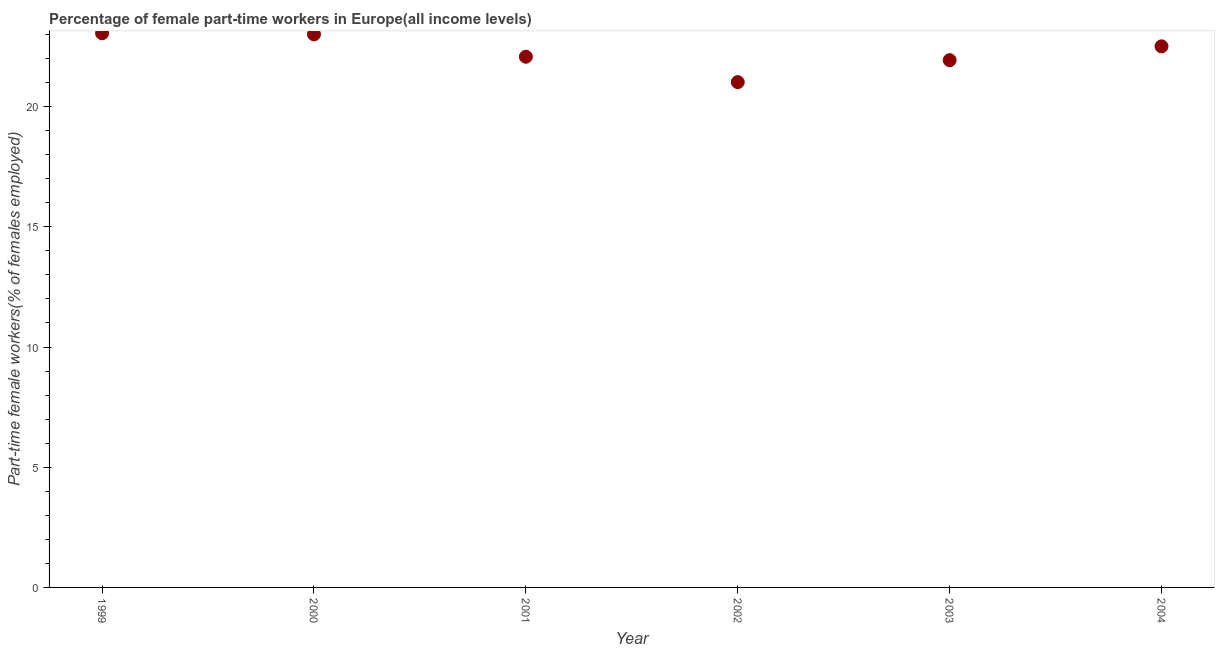What is the percentage of part-time female workers in 1999?
Provide a short and direct response. 23.05. Across all years, what is the maximum percentage of part-time female workers?
Your answer should be compact. 23.05. Across all years, what is the minimum percentage of part-time female workers?
Provide a short and direct response. 21.02. In which year was the percentage of part-time female workers maximum?
Your response must be concise. 1999. In which year was the percentage of part-time female workers minimum?
Keep it short and to the point. 2002. What is the sum of the percentage of part-time female workers?
Provide a short and direct response. 133.58. What is the difference between the percentage of part-time female workers in 1999 and 2001?
Keep it short and to the point. 0.98. What is the average percentage of part-time female workers per year?
Your answer should be compact. 22.26. What is the median percentage of part-time female workers?
Make the answer very short. 22.29. Do a majority of the years between 2003 and 2002 (inclusive) have percentage of part-time female workers greater than 22 %?
Ensure brevity in your answer.  No. What is the ratio of the percentage of part-time female workers in 1999 to that in 2004?
Your answer should be very brief. 1.02. Is the percentage of part-time female workers in 2001 less than that in 2003?
Your answer should be very brief. No. Is the difference between the percentage of part-time female workers in 2002 and 2003 greater than the difference between any two years?
Give a very brief answer. No. What is the difference between the highest and the second highest percentage of part-time female workers?
Offer a terse response. 0.04. What is the difference between the highest and the lowest percentage of part-time female workers?
Your response must be concise. 2.03. Does the graph contain any zero values?
Your answer should be compact. No. Does the graph contain grids?
Offer a very short reply. No. What is the title of the graph?
Your answer should be compact. Percentage of female part-time workers in Europe(all income levels). What is the label or title of the X-axis?
Give a very brief answer. Year. What is the label or title of the Y-axis?
Make the answer very short. Part-time female workers(% of females employed). What is the Part-time female workers(% of females employed) in 1999?
Make the answer very short. 23.05. What is the Part-time female workers(% of females employed) in 2000?
Ensure brevity in your answer.  23. What is the Part-time female workers(% of females employed) in 2001?
Your response must be concise. 22.07. What is the Part-time female workers(% of females employed) in 2002?
Your answer should be very brief. 21.02. What is the Part-time female workers(% of females employed) in 2003?
Make the answer very short. 21.93. What is the Part-time female workers(% of females employed) in 2004?
Ensure brevity in your answer.  22.51. What is the difference between the Part-time female workers(% of females employed) in 1999 and 2000?
Provide a succinct answer. 0.04. What is the difference between the Part-time female workers(% of females employed) in 1999 and 2001?
Your answer should be compact. 0.98. What is the difference between the Part-time female workers(% of females employed) in 1999 and 2002?
Keep it short and to the point. 2.03. What is the difference between the Part-time female workers(% of females employed) in 1999 and 2003?
Your answer should be very brief. 1.12. What is the difference between the Part-time female workers(% of females employed) in 1999 and 2004?
Keep it short and to the point. 0.54. What is the difference between the Part-time female workers(% of females employed) in 2000 and 2001?
Provide a short and direct response. 0.93. What is the difference between the Part-time female workers(% of females employed) in 2000 and 2002?
Keep it short and to the point. 1.99. What is the difference between the Part-time female workers(% of females employed) in 2000 and 2003?
Offer a very short reply. 1.07. What is the difference between the Part-time female workers(% of females employed) in 2000 and 2004?
Keep it short and to the point. 0.5. What is the difference between the Part-time female workers(% of females employed) in 2001 and 2002?
Provide a succinct answer. 1.06. What is the difference between the Part-time female workers(% of females employed) in 2001 and 2003?
Your answer should be compact. 0.14. What is the difference between the Part-time female workers(% of females employed) in 2001 and 2004?
Your answer should be very brief. -0.43. What is the difference between the Part-time female workers(% of females employed) in 2002 and 2003?
Offer a terse response. -0.91. What is the difference between the Part-time female workers(% of females employed) in 2002 and 2004?
Provide a succinct answer. -1.49. What is the difference between the Part-time female workers(% of females employed) in 2003 and 2004?
Provide a succinct answer. -0.57. What is the ratio of the Part-time female workers(% of females employed) in 1999 to that in 2000?
Your answer should be compact. 1. What is the ratio of the Part-time female workers(% of females employed) in 1999 to that in 2001?
Your answer should be compact. 1.04. What is the ratio of the Part-time female workers(% of females employed) in 1999 to that in 2002?
Provide a succinct answer. 1.1. What is the ratio of the Part-time female workers(% of females employed) in 1999 to that in 2003?
Make the answer very short. 1.05. What is the ratio of the Part-time female workers(% of females employed) in 1999 to that in 2004?
Ensure brevity in your answer.  1.02. What is the ratio of the Part-time female workers(% of females employed) in 2000 to that in 2001?
Make the answer very short. 1.04. What is the ratio of the Part-time female workers(% of females employed) in 2000 to that in 2002?
Ensure brevity in your answer.  1.09. What is the ratio of the Part-time female workers(% of females employed) in 2000 to that in 2003?
Offer a terse response. 1.05. What is the ratio of the Part-time female workers(% of females employed) in 2000 to that in 2004?
Keep it short and to the point. 1.02. What is the ratio of the Part-time female workers(% of females employed) in 2001 to that in 2002?
Offer a terse response. 1.05. What is the ratio of the Part-time female workers(% of females employed) in 2001 to that in 2003?
Provide a short and direct response. 1.01. What is the ratio of the Part-time female workers(% of females employed) in 2002 to that in 2003?
Your answer should be very brief. 0.96. What is the ratio of the Part-time female workers(% of females employed) in 2002 to that in 2004?
Offer a very short reply. 0.93. What is the ratio of the Part-time female workers(% of females employed) in 2003 to that in 2004?
Give a very brief answer. 0.97. 